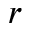Convert formula to latex. <formula><loc_0><loc_0><loc_500><loc_500>r</formula> 